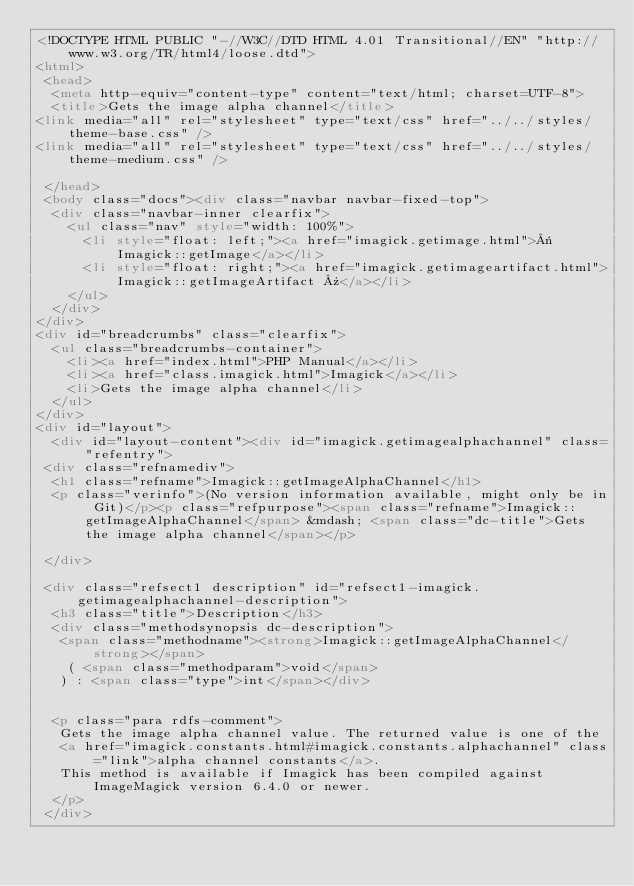Convert code to text. <code><loc_0><loc_0><loc_500><loc_500><_HTML_><!DOCTYPE HTML PUBLIC "-//W3C//DTD HTML 4.01 Transitional//EN" "http://www.w3.org/TR/html4/loose.dtd">
<html>
 <head>
  <meta http-equiv="content-type" content="text/html; charset=UTF-8">
  <title>Gets the image alpha channel</title>
<link media="all" rel="stylesheet" type="text/css" href="../../styles/theme-base.css" />
<link media="all" rel="stylesheet" type="text/css" href="../../styles/theme-medium.css" />

 </head>
 <body class="docs"><div class="navbar navbar-fixed-top">
  <div class="navbar-inner clearfix">
    <ul class="nav" style="width: 100%">
      <li style="float: left;"><a href="imagick.getimage.html">« Imagick::getImage</a></li>
      <li style="float: right;"><a href="imagick.getimageartifact.html">Imagick::getImageArtifact »</a></li>
    </ul>
  </div>
</div>
<div id="breadcrumbs" class="clearfix">
  <ul class="breadcrumbs-container">
    <li><a href="index.html">PHP Manual</a></li>
    <li><a href="class.imagick.html">Imagick</a></li>
    <li>Gets the image alpha channel</li>
  </ul>
</div>
<div id="layout">
  <div id="layout-content"><div id="imagick.getimagealphachannel" class="refentry">
 <div class="refnamediv">
  <h1 class="refname">Imagick::getImageAlphaChannel</h1>
  <p class="verinfo">(No version information available, might only be in Git)</p><p class="refpurpose"><span class="refname">Imagick::getImageAlphaChannel</span> &mdash; <span class="dc-title">Gets the image alpha channel</span></p>

 </div>

 <div class="refsect1 description" id="refsect1-imagick.getimagealphachannel-description">
  <h3 class="title">Description</h3>
  <div class="methodsynopsis dc-description">
   <span class="methodname"><strong>Imagick::getImageAlphaChannel</strong></span>
    ( <span class="methodparam">void</span>
   ) : <span class="type">int</span></div>


  <p class="para rdfs-comment">
   Gets the image alpha channel value. The returned value is one of the 
   <a href="imagick.constants.html#imagick.constants.alphachannel" class="link">alpha channel constants</a>.
   This method is available if Imagick has been compiled against ImageMagick version 6.4.0 or newer.
  </p>
 </div>

</code> 